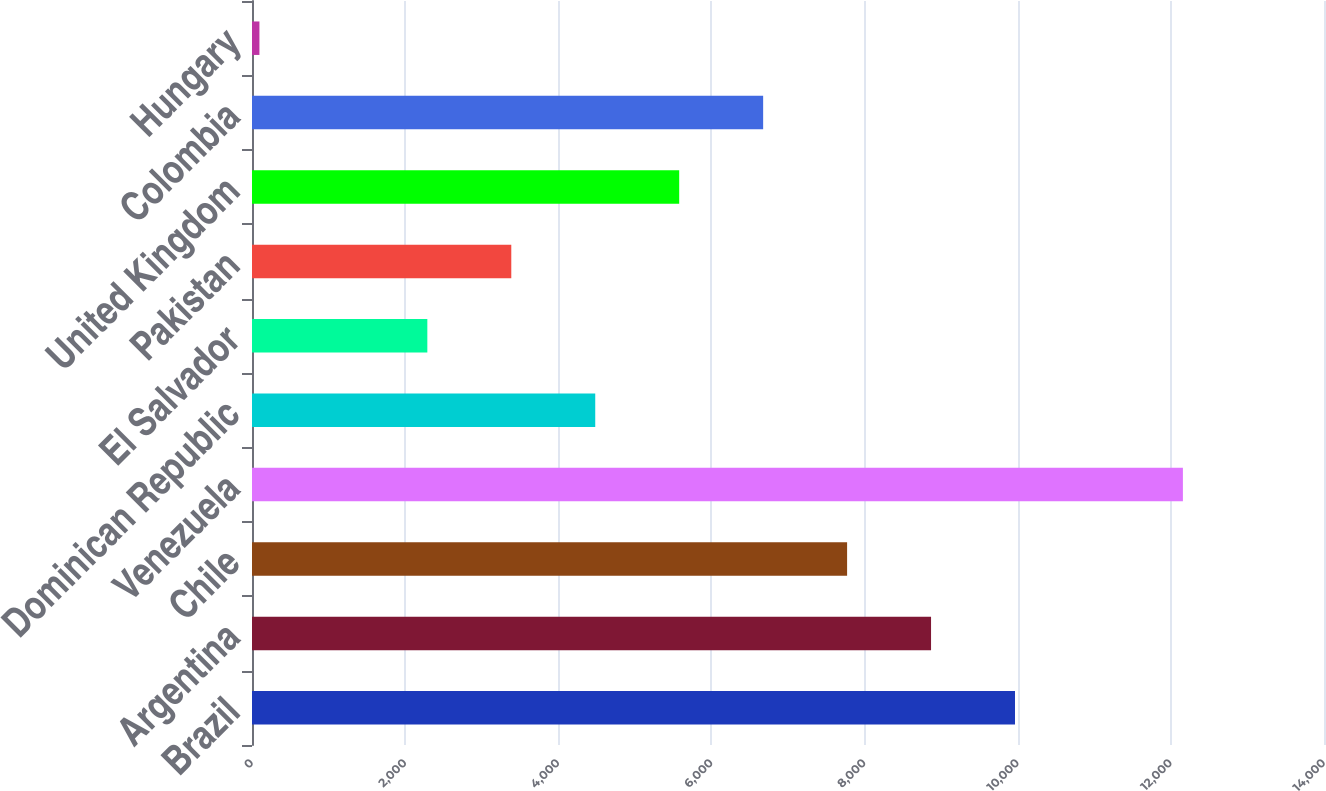<chart> <loc_0><loc_0><loc_500><loc_500><bar_chart><fcel>Brazil<fcel>Argentina<fcel>Chile<fcel>Venezuela<fcel>Dominican Republic<fcel>El Salvador<fcel>Pakistan<fcel>United Kingdom<fcel>Colombia<fcel>Hungary<nl><fcel>9964.6<fcel>8868.2<fcel>7771.8<fcel>12157.4<fcel>4482.6<fcel>2289.8<fcel>3386.2<fcel>5579<fcel>6675.4<fcel>97<nl></chart> 